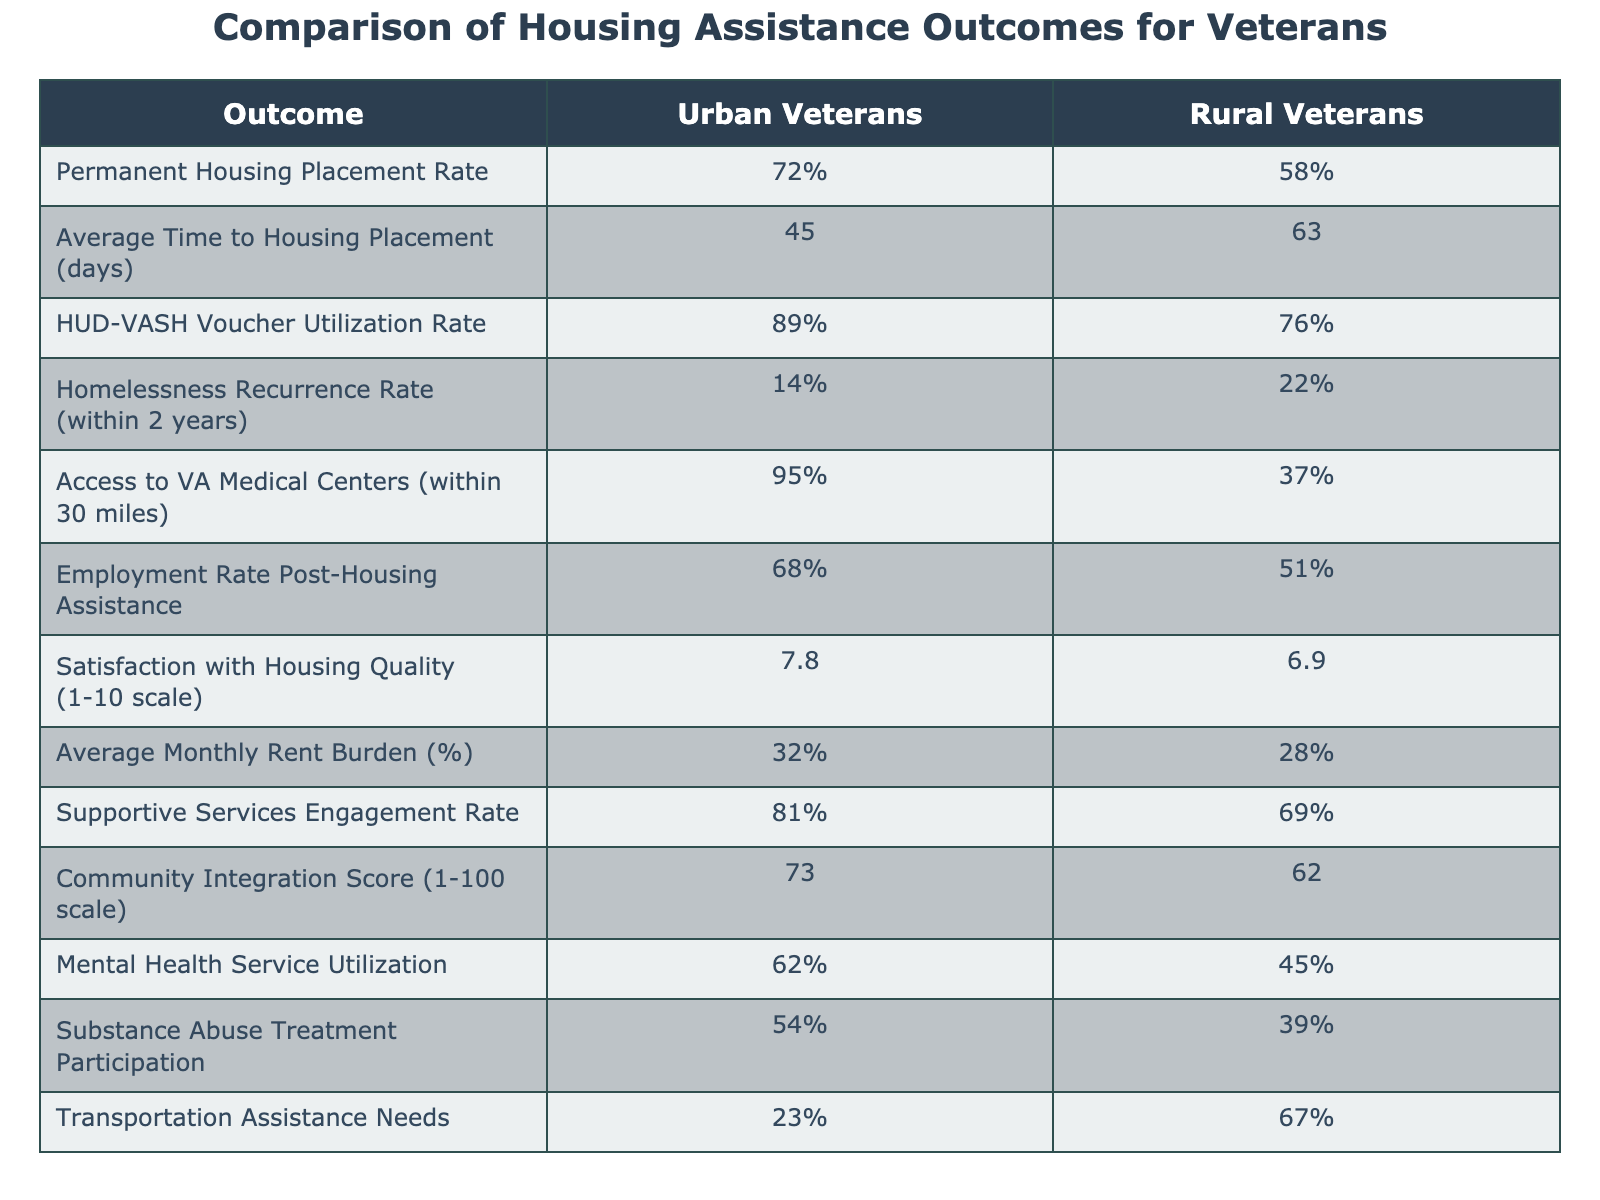What is the Permanent Housing Placement Rate for Urban Veterans? The table lists the Permanent Housing Placement Rate for Urban Veterans as 72%. Therefore, this is the direct retrieval from the data provided.
Answer: 72% What is the Average Time to Housing Placement for Rural Veterans? Referring to the table, the data shows that the Average Time to Housing Placement for Rural Veterans is 63 days. This value is directly retrieved from the table.
Answer: 63 days Is the HUD-VASH Voucher Utilization Rate higher for Urban or Rural Veterans? The HUD-VASH Voucher Utilization Rate for Urban Veterans is 89%, while for Rural Veterans, it is 76%. Since 89% is greater than 76%, Urban Veterans have a higher rate.
Answer: Yes, it is higher for Urban Veterans What is the difference in the Homelessness Recurrence Rate between Urban and Rural Veterans? For Urban Veterans, the Homelessness Recurrence Rate is 14%, and for Rural Veterans, it is 22%. The difference is obtained by subtracting 14% from 22%, which is 22% - 14% = 8%.
Answer: 8% What percentage of Rural Veterans have access to VA Medical Centers within 30 miles? The table indicates that 37% of Rural Veterans have access to VA Medical Centers within 30 miles. This is a direct retrieval from the table.
Answer: 37% What is the average Employment Rate for both Urban and Rural Veterans? The Employment Rate for Urban Veterans is 68% and for Rural Veterans is 51%. To find the average, we sum these rates (68 + 51 = 119) and divide by the number of groups (2). Thus, the average is 119/2 = 59.5%.
Answer: 59.5% Which group has a higher Satisfaction with Housing Quality? The Satisfaction with Housing Quality score for Urban Veterans is 7.8 while for Rural Veterans it is 6.9. Since 7.8 > 6.9, Urban Veterans have a higher score.
Answer: Urban Veterans How many percentage points higher is the Supportive Services Engagement Rate for Urban Veterans compared to Rural Veterans? The Supportive Services Engagement Rate for Urban Veterans is 81% and for Rural Veterans is 69%. The difference is 81% - 69% = 12 percentage points.
Answer: 12 percentage points Do more Urban or Rural Veterans utilize Mental Health Services? The data shows that 62% of Urban Veterans utilize Mental Health Services while only 45% of Rural Veterans do. Since 62% is greater than 45%, more Urban Veterans utilize these services.
Answer: More Urban Veterans What is the Community Integration Score for both Urban and Rural Veterans? From the table, the Community Integration Score for Urban Veterans is 73, and for Rural Veterans, it is 62. This is a simple retrieval of data from the table.
Answer: Urban: 73, Rural: 62 If Transportation Assistance Needs are expressed as a percentage, what percentage of Rural Veterans need this assistance? The table shows that 67% of Rural Veterans need Transportation Assistance. This is a direct lookup from the data provided.
Answer: 67% 